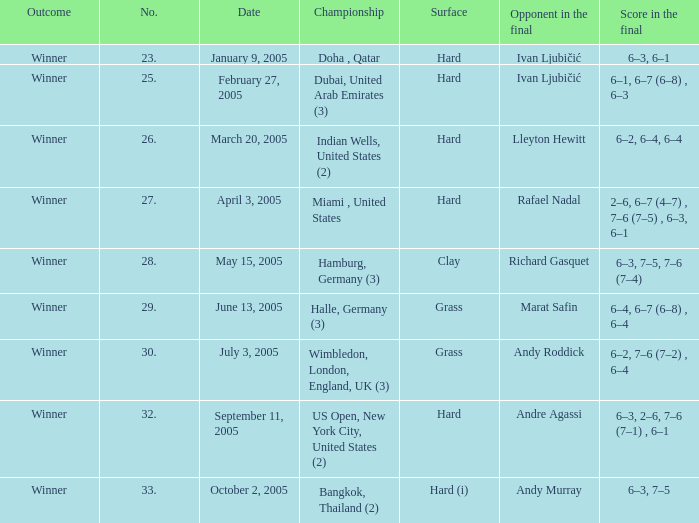Marat Safin is the opponent in the final in what championship? Halle, Germany (3). 